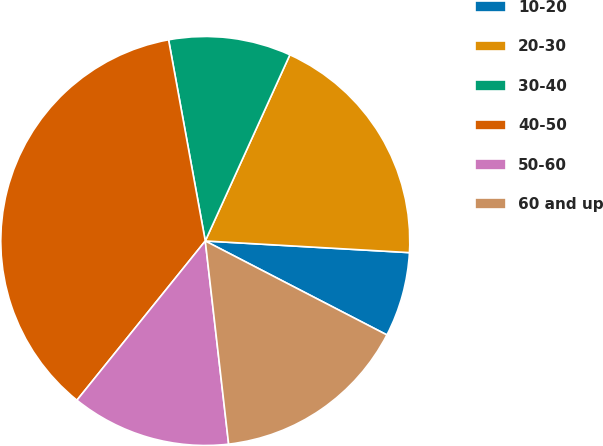Convert chart. <chart><loc_0><loc_0><loc_500><loc_500><pie_chart><fcel>10-20<fcel>20-30<fcel>30-40<fcel>40-50<fcel>50-60<fcel>60 and up<nl><fcel>6.69%<fcel>19.12%<fcel>9.66%<fcel>36.33%<fcel>12.62%<fcel>15.58%<nl></chart> 